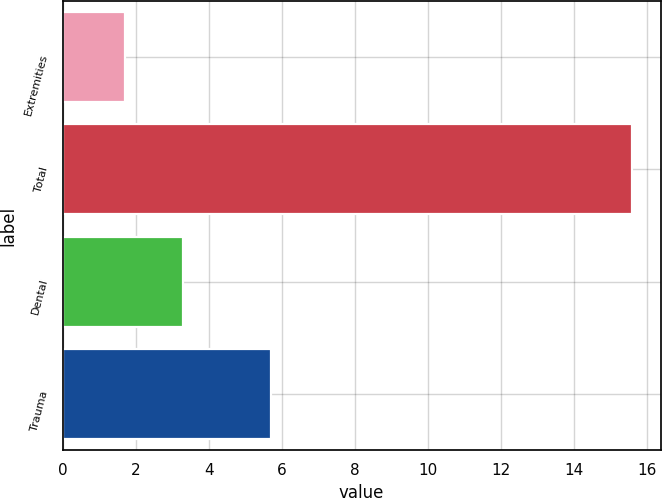Convert chart to OTSL. <chart><loc_0><loc_0><loc_500><loc_500><bar_chart><fcel>Extremities<fcel>Total<fcel>Dental<fcel>Trauma<nl><fcel>1.7<fcel>15.6<fcel>3.3<fcel>5.7<nl></chart> 